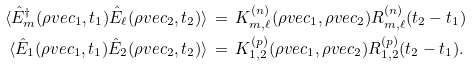Convert formula to latex. <formula><loc_0><loc_0><loc_500><loc_500>\, \langle \hat { E } _ { m } ^ { \dagger } ( \rho v e c _ { 1 } , t _ { 1 } ) \hat { E } _ { \ell } ( \rho v e c _ { 2 } , t _ { 2 } ) \rangle \, & = \, K ^ { ( n ) } _ { m , \ell } ( \rho v e c _ { 1 } , \rho v e c _ { 2 } ) R ^ { ( n ) } _ { m , \ell } ( t _ { 2 } - t _ { 1 } ) \\ \, \langle \hat { E } _ { 1 } ( \rho v e c _ { 1 } , t _ { 1 } ) \hat { E } _ { 2 } ( \rho v e c _ { 2 } , t _ { 2 } ) \rangle \, & = \, K ^ { ( p ) } _ { 1 , 2 } ( \rho v e c _ { 1 } , \rho v e c _ { 2 } ) R ^ { ( p ) } _ { 1 , 2 } ( t _ { 2 } - t _ { 1 } ) .</formula> 